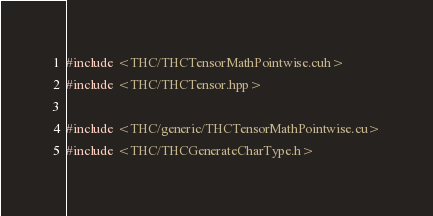Convert code to text. <code><loc_0><loc_0><loc_500><loc_500><_Cuda_>#include <THC/THCTensorMathPointwise.cuh>
#include <THC/THCTensor.hpp>

#include <THC/generic/THCTensorMathPointwise.cu>
#include <THC/THCGenerateCharType.h>
</code> 